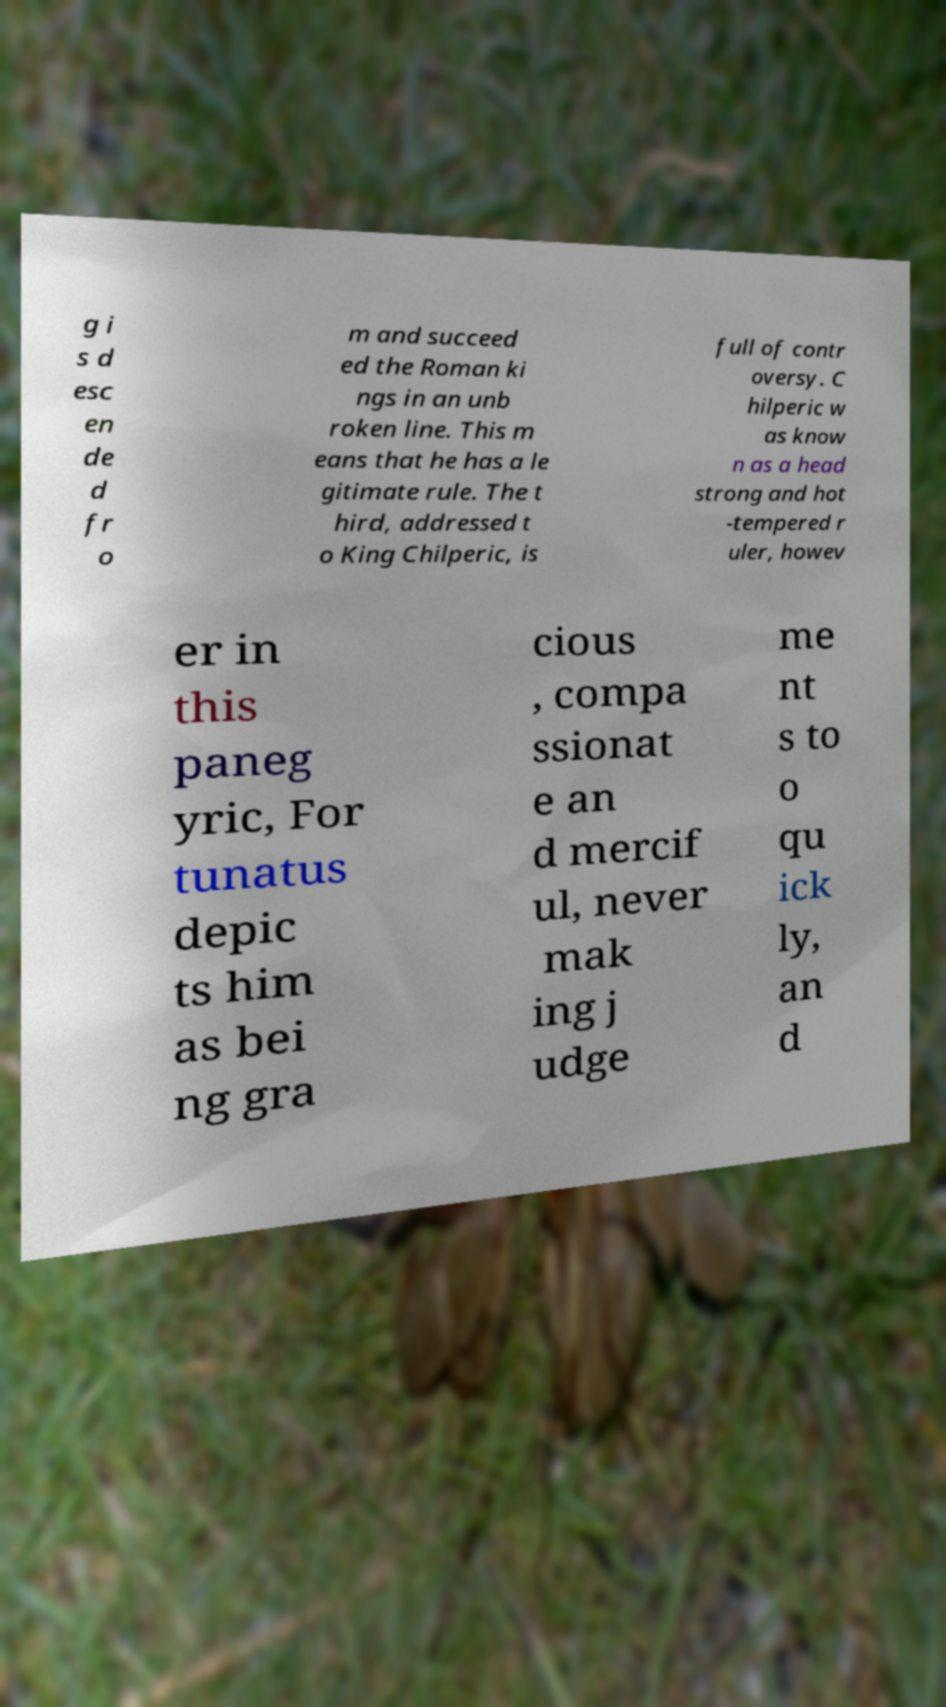For documentation purposes, I need the text within this image transcribed. Could you provide that? g i s d esc en de d fr o m and succeed ed the Roman ki ngs in an unb roken line. This m eans that he has a le gitimate rule. The t hird, addressed t o King Chilperic, is full of contr oversy. C hilperic w as know n as a head strong and hot -tempered r uler, howev er in this paneg yric, For tunatus depic ts him as bei ng gra cious , compa ssionat e an d mercif ul, never mak ing j udge me nt s to o qu ick ly, an d 